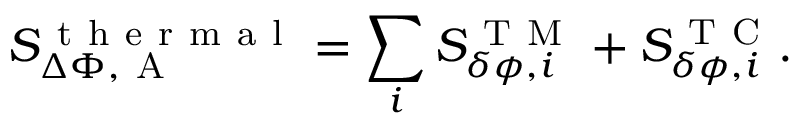Convert formula to latex. <formula><loc_0><loc_0><loc_500><loc_500>S _ { \Delta \Phi , A } ^ { t h e r m a l } = \sum _ { i } S _ { \delta \phi , i } ^ { T M } + S _ { \delta \phi , i } ^ { T C } .</formula> 